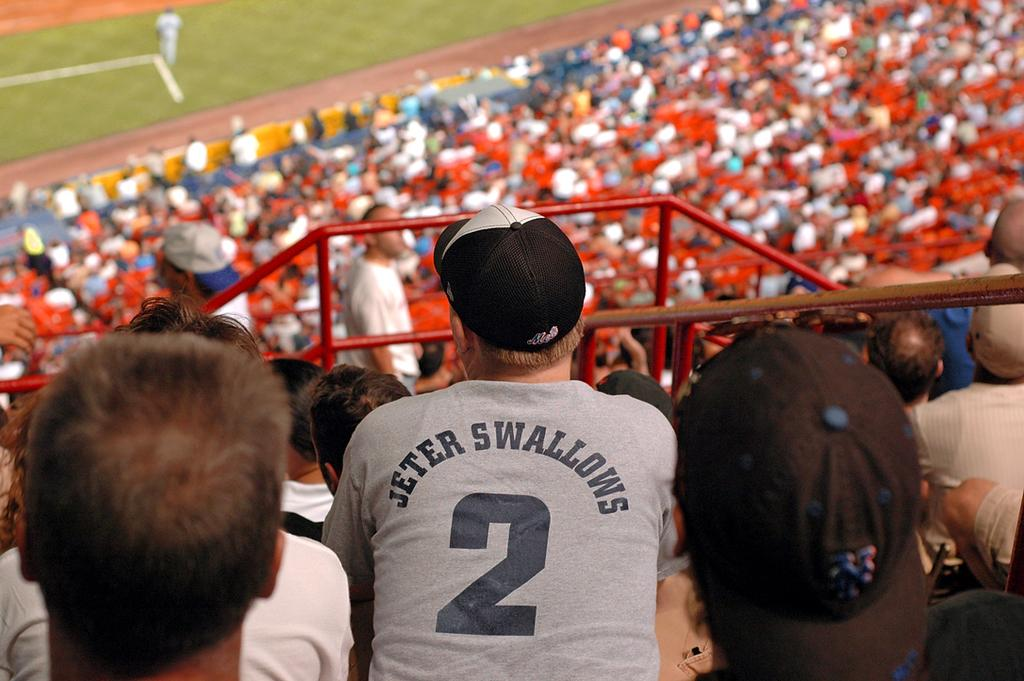<image>
Share a concise interpretation of the image provided. Back of a baseball fan sitting in a stadium  shows a joke about Jeter. 